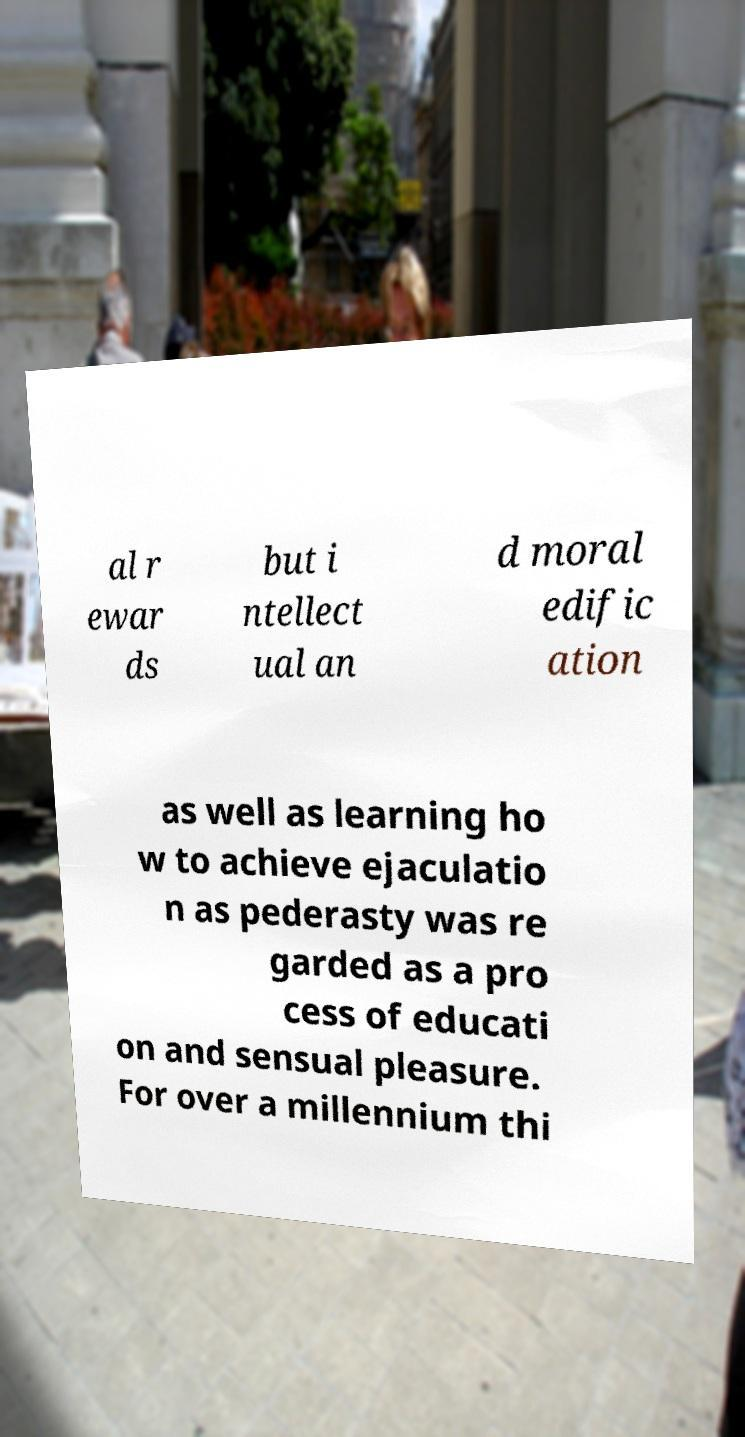Could you extract and type out the text from this image? al r ewar ds but i ntellect ual an d moral edific ation as well as learning ho w to achieve ejaculatio n as pederasty was re garded as a pro cess of educati on and sensual pleasure. For over a millennium thi 